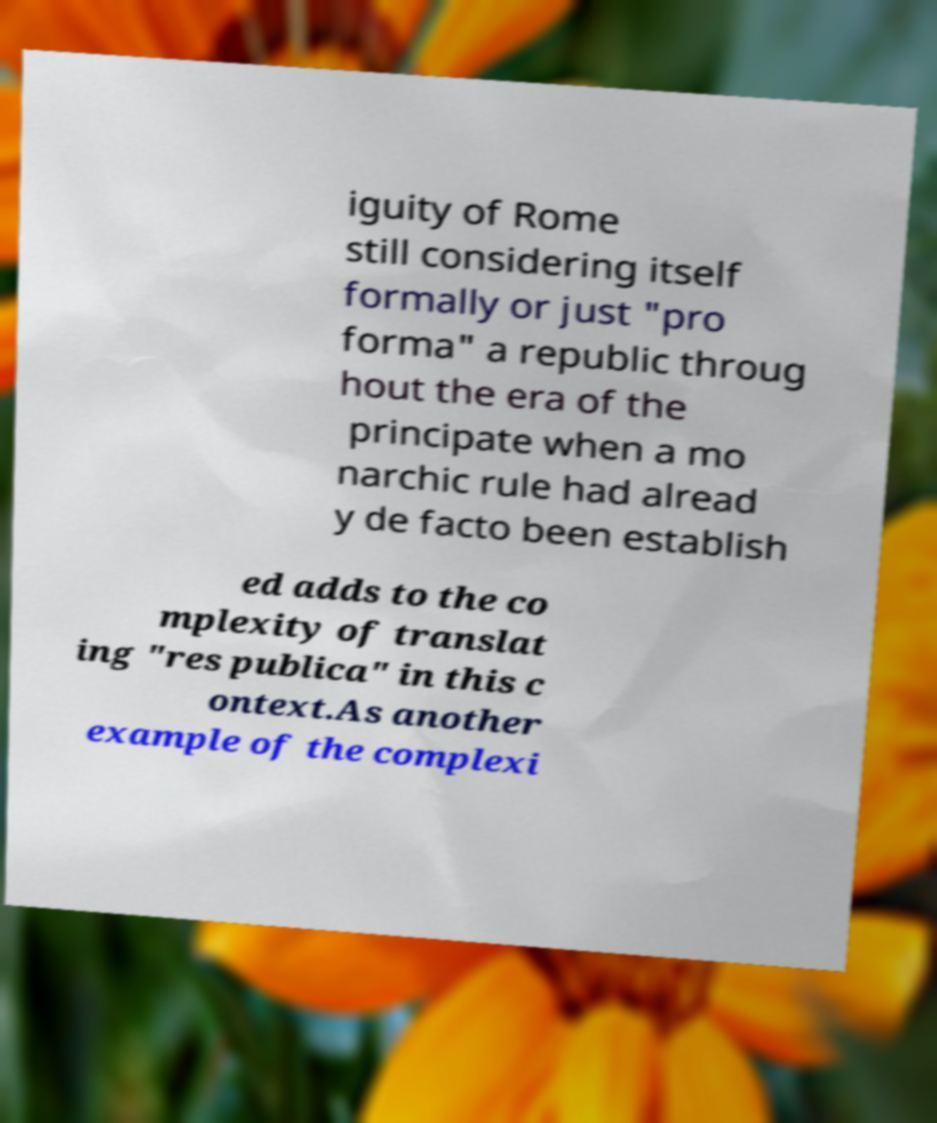There's text embedded in this image that I need extracted. Can you transcribe it verbatim? iguity of Rome still considering itself formally or just "pro forma" a republic throug hout the era of the principate when a mo narchic rule had alread y de facto been establish ed adds to the co mplexity of translat ing "res publica" in this c ontext.As another example of the complexi 